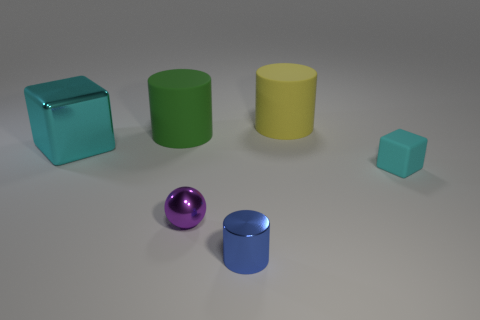Does the big cyan object have the same material as the large cylinder that is on the right side of the shiny cylinder? The big cyan object, which appears to be a cube, and the large yellow cylinder on the right side of the shiny spherical object do not seem to have the same surface characteristics. The cyan cube has a glass-like transparent appearance, suggesting it is made of some kind of glass or plastic material. On the other hand, the yellow cylinder has an opaque surface that reflects light diffusely, indicative of a more matte material like painted metal or plastic. 